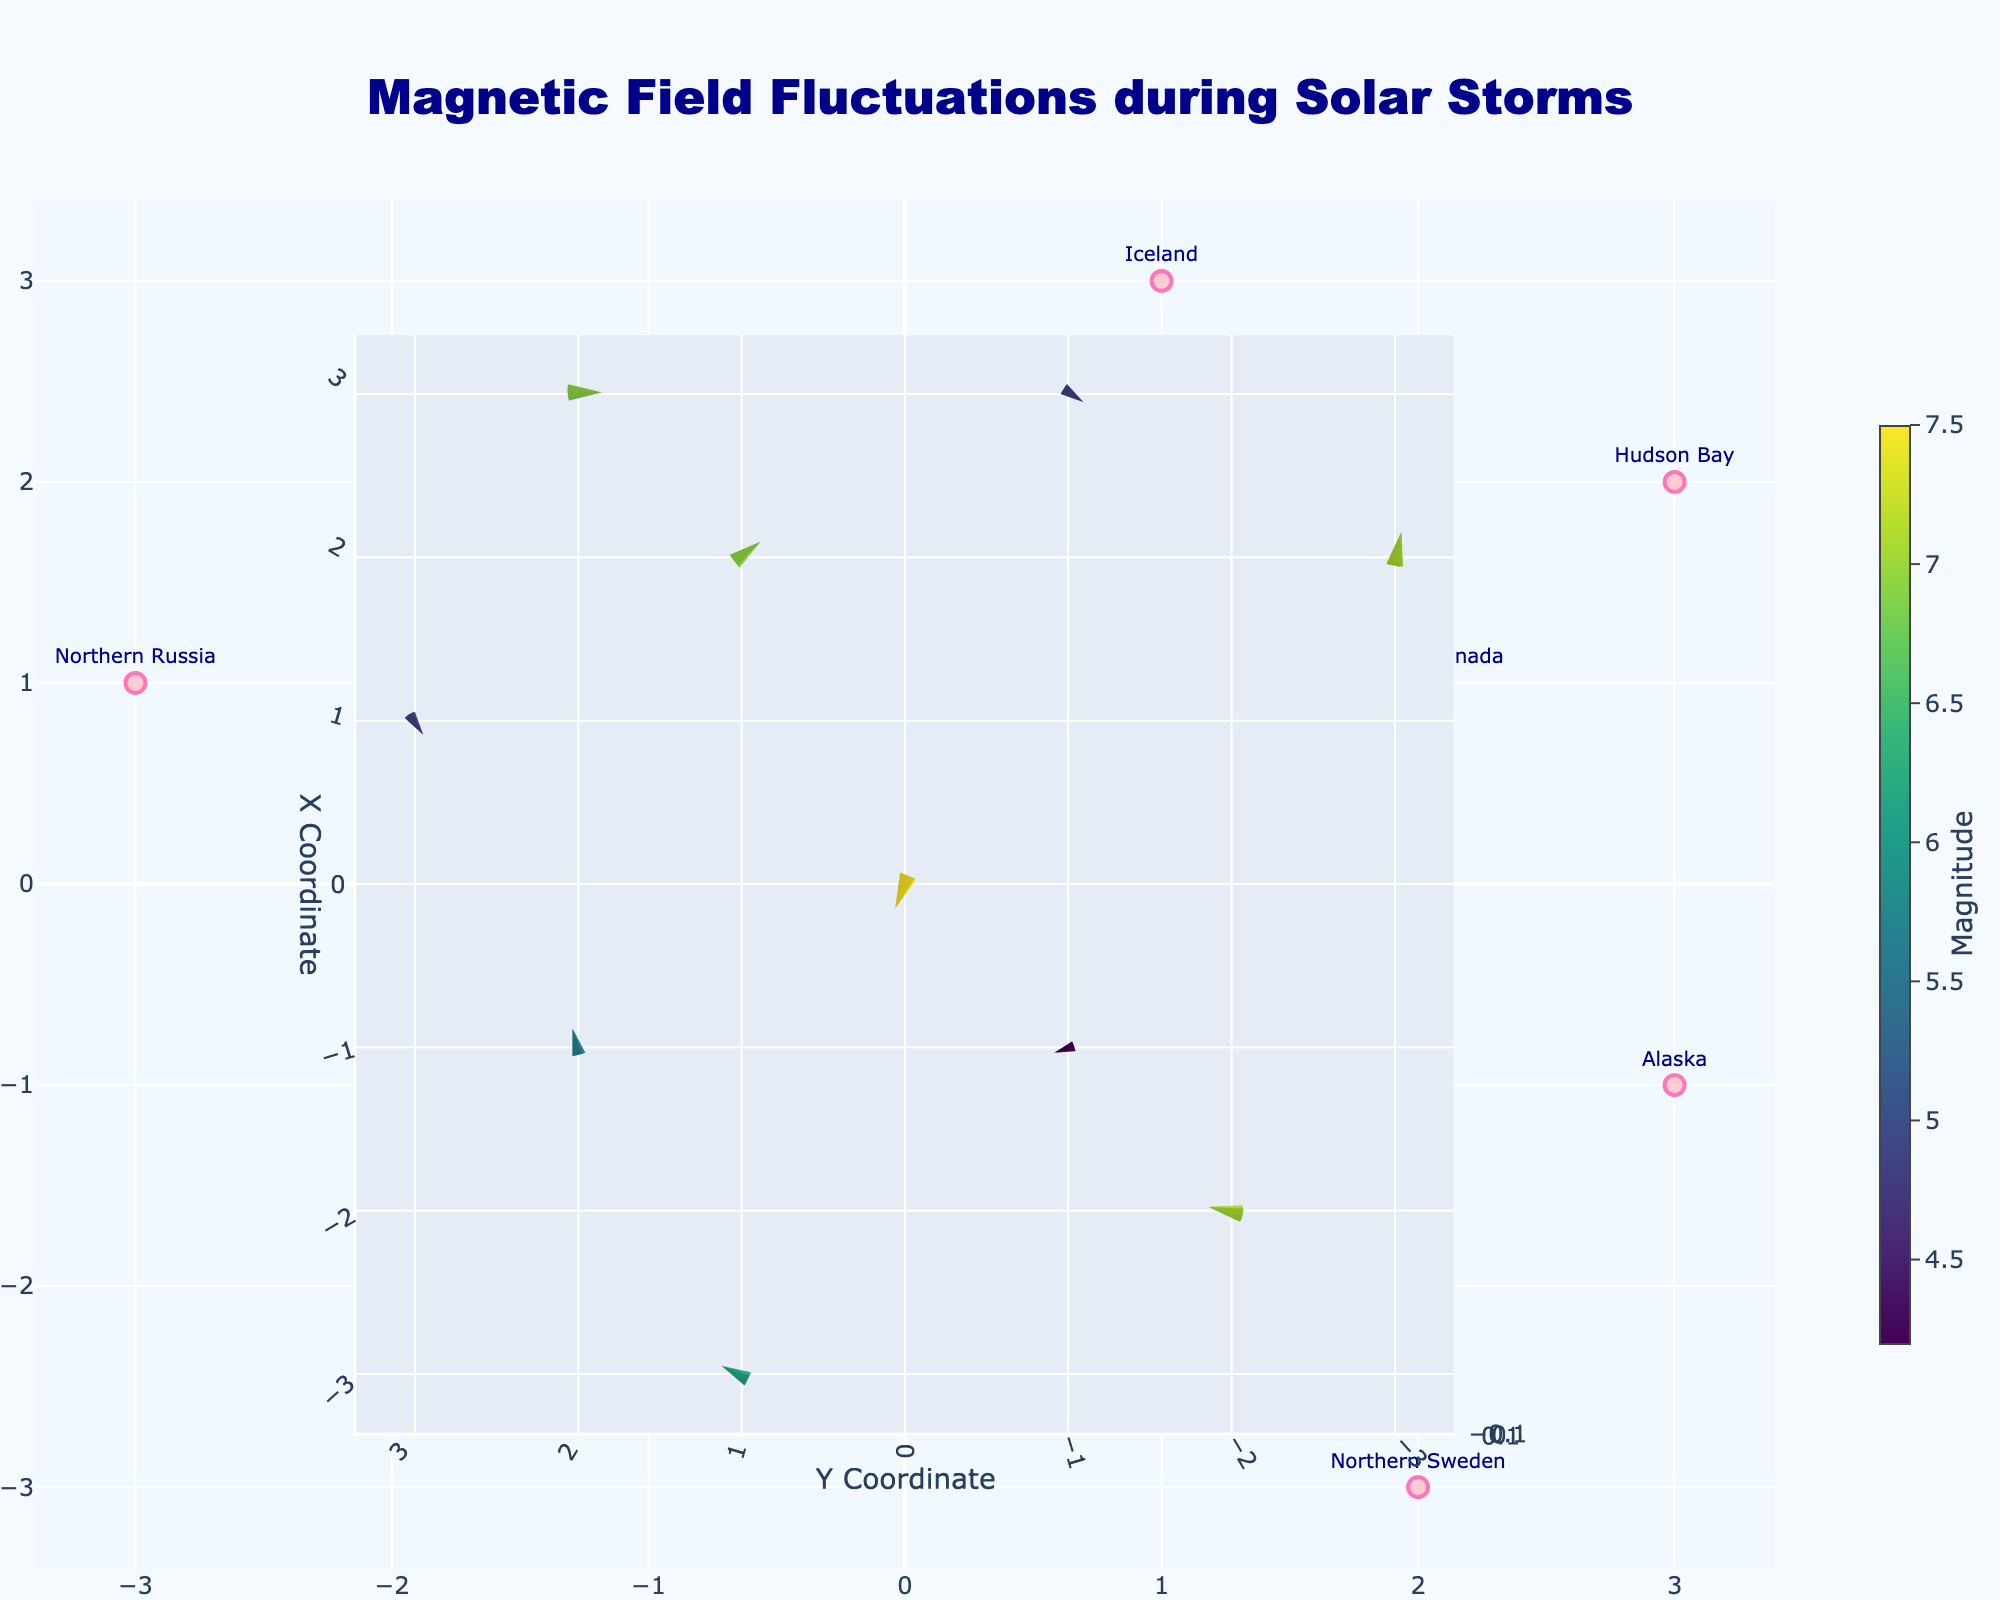Which location shows the largest magnitude of magnetic field fluctuation? Identify the location with the highest value in the 'magnitude' column and cross-reference with the plotted figure. This specific value would be represented with the longest vector on the quiver plot.
Answer: Greenland What are the coordinates of the location with the lowest magnetic field magnitude? Look for the lowest value in the 'magnitude' column and find the corresponding x and y coordinates. The smallest vector on the quiver plot represents this value.
Answer: (-1, -1) Compare the directions of magnetic field fluctuations in Alaska and Northern Sweden. Are they similar? Analyze the vectors from both Alaska and Northern Sweden. Alaska's vector is (-2, -3) while Northern Sweden's vector is (5, -1). The directions are different.
Answer: No What is the average magnitude of the magnetic field fluctuations of the locations in the Arctic region (Greenland, Northern Canada, and Alaska)? Retrieve the magnitudes for Greenland, Northern Canada, and Alaska. The magnitudes are 7.5, 6.2, and 4.9, respectively. The average is calculated as (7.5 + 6.2 + 4.9) / 3 = 6.2.
Answer: 6.2 In which direction is the magnetic field fluctuation in Norway heading? Look at the vector associated with Norway, which is (1, 5). This indicates the direction is towards positive x and y directions.
Answer: Positive x and y direction Identify any location where the magnetic field fluctuation vector is pointing directly downwards. Look for any location with a downward vector. Hudson Bay has a vector direction of (0, -5), indicating a direct downward direction.
Answer: Hudson Bay Which location has both the x and y components of the magnetic field fluctuations being negative? Check the vector values to find a location where both u and v are negative. Alaska's vector components are (-2, -3), which are both negative.
Answer: Alaska What overall pattern do you observe in terms of the magnitude of magnetic field fluctuations from the plotted data? Evaluating the vectors' lengths in different locations and noting from the figure, higher magnitudes are often represented by longer vectors. Distinct regions such as Greenland and Hudson Bay have relatively higher magnitudes.
Answer: Higher magnitudes in Greenland and Hudson Bay Which two locations have the vectors with the same or similar magnitude of magnetic field fluctuations? Compare the 'magnitude' column for values that are close to each other. Iceland and Northern Russia have similar magnitudes of 5.1 and 5.5, respectively.
Answer: Iceland and Northern Russia 